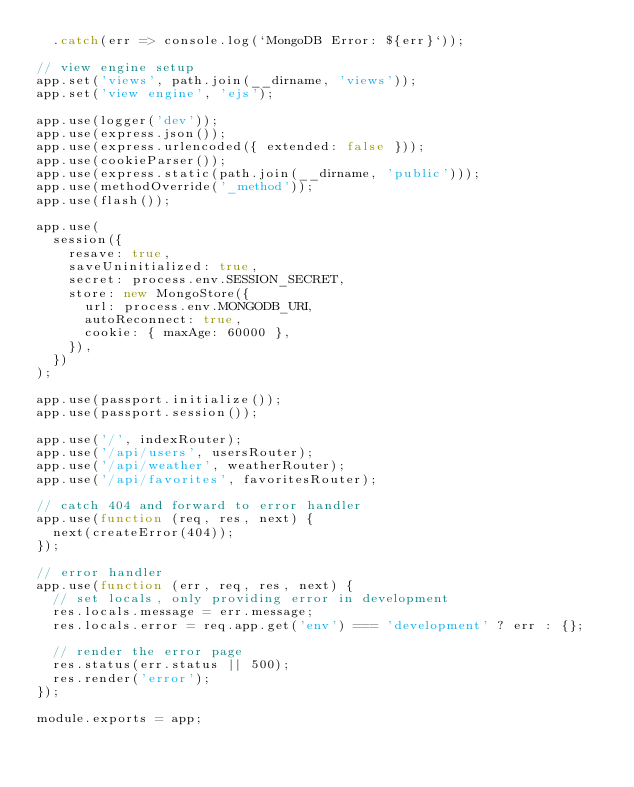<code> <loc_0><loc_0><loc_500><loc_500><_JavaScript_>  .catch(err => console.log(`MongoDB Error: ${err}`));

// view engine setup
app.set('views', path.join(__dirname, 'views'));
app.set('view engine', 'ejs');

app.use(logger('dev'));
app.use(express.json());
app.use(express.urlencoded({ extended: false }));
app.use(cookieParser());
app.use(express.static(path.join(__dirname, 'public')));
app.use(methodOverride('_method'));
app.use(flash());

app.use(
  session({
    resave: true,
    saveUninitialized: true,
    secret: process.env.SESSION_SECRET,
    store: new MongoStore({
      url: process.env.MONGODB_URI,
      autoReconnect: true,
      cookie: { maxAge: 60000 },
    }),
  })
);

app.use(passport.initialize());
app.use(passport.session());

app.use('/', indexRouter);
app.use('/api/users', usersRouter);
app.use('/api/weather', weatherRouter);
app.use('/api/favorites', favoritesRouter);

// catch 404 and forward to error handler
app.use(function (req, res, next) {
  next(createError(404));
});

// error handler
app.use(function (err, req, res, next) {
  // set locals, only providing error in development
  res.locals.message = err.message;
  res.locals.error = req.app.get('env') === 'development' ? err : {};

  // render the error page
  res.status(err.status || 500);
  res.render('error');
});

module.exports = app;
</code> 